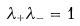<formula> <loc_0><loc_0><loc_500><loc_500>\lambda _ { + } \lambda _ { - } = 1</formula> 